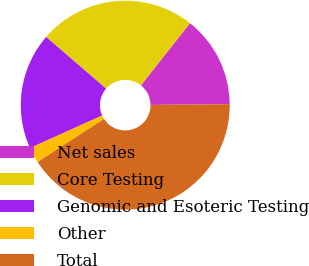<chart> <loc_0><loc_0><loc_500><loc_500><pie_chart><fcel>Net sales<fcel>Core Testing<fcel>Genomic and Esoteric Testing<fcel>Other<fcel>Total<nl><fcel>14.21%<fcel>24.31%<fcel>18.06%<fcel>2.42%<fcel>40.99%<nl></chart> 